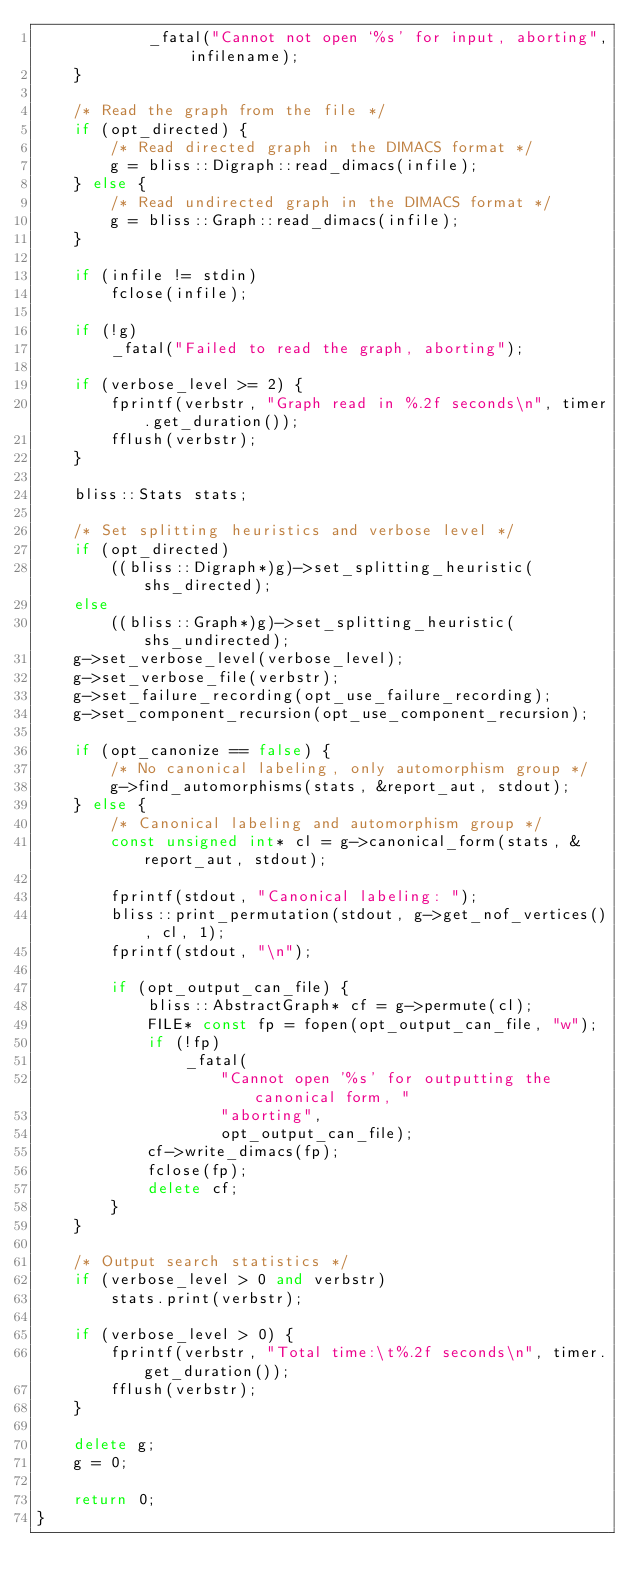Convert code to text. <code><loc_0><loc_0><loc_500><loc_500><_C++_>            _fatal("Cannot not open `%s' for input, aborting", infilename);
    }

    /* Read the graph from the file */
    if (opt_directed) {
        /* Read directed graph in the DIMACS format */
        g = bliss::Digraph::read_dimacs(infile);
    } else {
        /* Read undirected graph in the DIMACS format */
        g = bliss::Graph::read_dimacs(infile);
    }

    if (infile != stdin)
        fclose(infile);

    if (!g)
        _fatal("Failed to read the graph, aborting");

    if (verbose_level >= 2) {
        fprintf(verbstr, "Graph read in %.2f seconds\n", timer.get_duration());
        fflush(verbstr);
    }

    bliss::Stats stats;

    /* Set splitting heuristics and verbose level */
    if (opt_directed)
        ((bliss::Digraph*)g)->set_splitting_heuristic(shs_directed);
    else
        ((bliss::Graph*)g)->set_splitting_heuristic(shs_undirected);
    g->set_verbose_level(verbose_level);
    g->set_verbose_file(verbstr);
    g->set_failure_recording(opt_use_failure_recording);
    g->set_component_recursion(opt_use_component_recursion);

    if (opt_canonize == false) {
        /* No canonical labeling, only automorphism group */
        g->find_automorphisms(stats, &report_aut, stdout);
    } else {
        /* Canonical labeling and automorphism group */
        const unsigned int* cl = g->canonical_form(stats, &report_aut, stdout);

        fprintf(stdout, "Canonical labeling: ");
        bliss::print_permutation(stdout, g->get_nof_vertices(), cl, 1);
        fprintf(stdout, "\n");

        if (opt_output_can_file) {
            bliss::AbstractGraph* cf = g->permute(cl);
            FILE* const fp = fopen(opt_output_can_file, "w");
            if (!fp)
                _fatal(
                    "Cannot open '%s' for outputting the canonical form, "
                    "aborting",
                    opt_output_can_file);
            cf->write_dimacs(fp);
            fclose(fp);
            delete cf;
        }
    }

    /* Output search statistics */
    if (verbose_level > 0 and verbstr)
        stats.print(verbstr);

    if (verbose_level > 0) {
        fprintf(verbstr, "Total time:\t%.2f seconds\n", timer.get_duration());
        fflush(verbstr);
    }

    delete g;
    g = 0;

    return 0;
}
</code> 